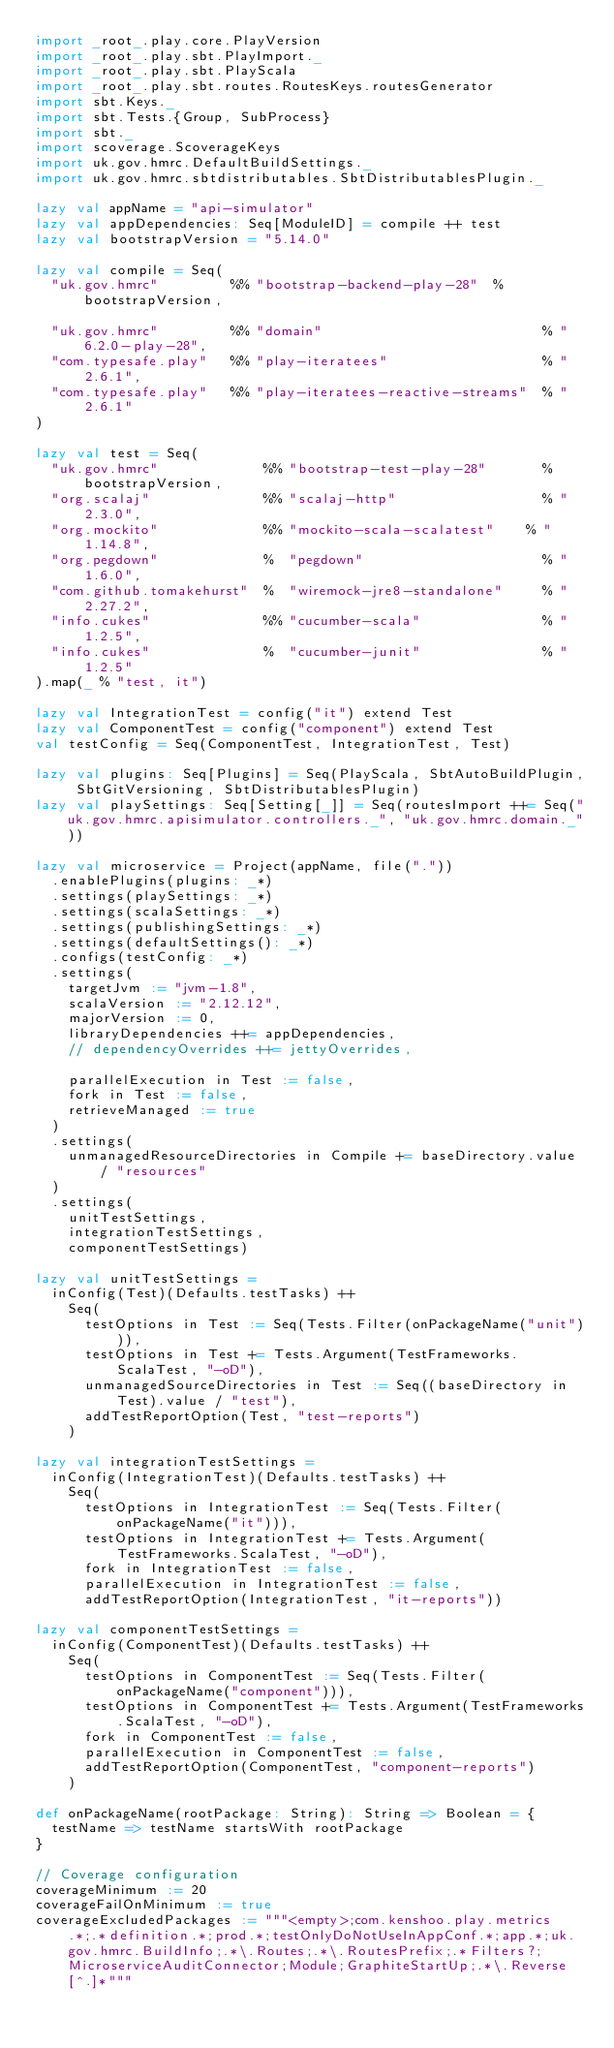Convert code to text. <code><loc_0><loc_0><loc_500><loc_500><_Scala_>import _root_.play.core.PlayVersion
import _root_.play.sbt.PlayImport._
import _root_.play.sbt.PlayScala
import _root_.play.sbt.routes.RoutesKeys.routesGenerator
import sbt.Keys._
import sbt.Tests.{Group, SubProcess}
import sbt._
import scoverage.ScoverageKeys
import uk.gov.hmrc.DefaultBuildSettings._
import uk.gov.hmrc.sbtdistributables.SbtDistributablesPlugin._

lazy val appName = "api-simulator"
lazy val appDependencies: Seq[ModuleID] = compile ++ test
lazy val bootstrapVersion = "5.14.0"

lazy val compile = Seq(
  "uk.gov.hmrc"         %% "bootstrap-backend-play-28"  %  bootstrapVersion,

  "uk.gov.hmrc"         %% "domain"                           % "6.2.0-play-28",
  "com.typesafe.play"   %% "play-iteratees"                   % "2.6.1",
  "com.typesafe.play"   %% "play-iteratees-reactive-streams"  % "2.6.1"
)

lazy val test = Seq(
  "uk.gov.hmrc"             %% "bootstrap-test-play-28"       % bootstrapVersion,
  "org.scalaj"              %% "scalaj-http"                  % "2.3.0",
  "org.mockito"             %% "mockito-scala-scalatest"    % "1.14.8",
  "org.pegdown"             %  "pegdown"                      % "1.6.0",
  "com.github.tomakehurst"  %  "wiremock-jre8-standalone"     % "2.27.2",
  "info.cukes"              %% "cucumber-scala"               % "1.2.5",
  "info.cukes"              %  "cucumber-junit"               % "1.2.5"
).map(_ % "test, it")

lazy val IntegrationTest = config("it") extend Test
lazy val ComponentTest = config("component") extend Test
val testConfig = Seq(ComponentTest, IntegrationTest, Test)

lazy val plugins: Seq[Plugins] = Seq(PlayScala, SbtAutoBuildPlugin, SbtGitVersioning, SbtDistributablesPlugin)
lazy val playSettings: Seq[Setting[_]] = Seq(routesImport ++= Seq("uk.gov.hmrc.apisimulator.controllers._", "uk.gov.hmrc.domain._"))

lazy val microservice = Project(appName, file("."))
  .enablePlugins(plugins: _*)
  .settings(playSettings: _*)
  .settings(scalaSettings: _*)
  .settings(publishingSettings: _*)
  .settings(defaultSettings(): _*)
  .configs(testConfig: _*)
  .settings(
    targetJvm := "jvm-1.8",
    scalaVersion := "2.12.12",
    majorVersion := 0,
    libraryDependencies ++= appDependencies,
    // dependencyOverrides ++= jettyOverrides,

    parallelExecution in Test := false,
    fork in Test := false,
    retrieveManaged := true
  )
  .settings(
    unmanagedResourceDirectories in Compile += baseDirectory.value / "resources"
  )
  .settings(
    unitTestSettings,
    integrationTestSettings,
    componentTestSettings)

lazy val unitTestSettings =
  inConfig(Test)(Defaults.testTasks) ++
    Seq(
      testOptions in Test := Seq(Tests.Filter(onPackageName("unit"))),
      testOptions in Test += Tests.Argument(TestFrameworks.ScalaTest, "-oD"),
      unmanagedSourceDirectories in Test := Seq((baseDirectory in Test).value / "test"),
      addTestReportOption(Test, "test-reports")
    )

lazy val integrationTestSettings =
  inConfig(IntegrationTest)(Defaults.testTasks) ++
    Seq(
      testOptions in IntegrationTest := Seq(Tests.Filter(onPackageName("it"))),
      testOptions in IntegrationTest += Tests.Argument(TestFrameworks.ScalaTest, "-oD"),
      fork in IntegrationTest := false,
      parallelExecution in IntegrationTest := false,
      addTestReportOption(IntegrationTest, "it-reports"))

lazy val componentTestSettings =
  inConfig(ComponentTest)(Defaults.testTasks) ++
    Seq(
      testOptions in ComponentTest := Seq(Tests.Filter(onPackageName("component"))),
      testOptions in ComponentTest += Tests.Argument(TestFrameworks.ScalaTest, "-oD"),
      fork in ComponentTest := false,
      parallelExecution in ComponentTest := false,
      addTestReportOption(ComponentTest, "component-reports")
    )

def onPackageName(rootPackage: String): String => Boolean = {
  testName => testName startsWith rootPackage
}

// Coverage configuration
coverageMinimum := 20
coverageFailOnMinimum := true
coverageExcludedPackages := """<empty>;com.kenshoo.play.metrics.*;.*definition.*;prod.*;testOnlyDoNotUseInAppConf.*;app.*;uk.gov.hmrc.BuildInfo;.*\.Routes;.*\.RoutesPrefix;.*Filters?;MicroserviceAuditConnector;Module;GraphiteStartUp;.*\.Reverse[^.]*"""



</code> 